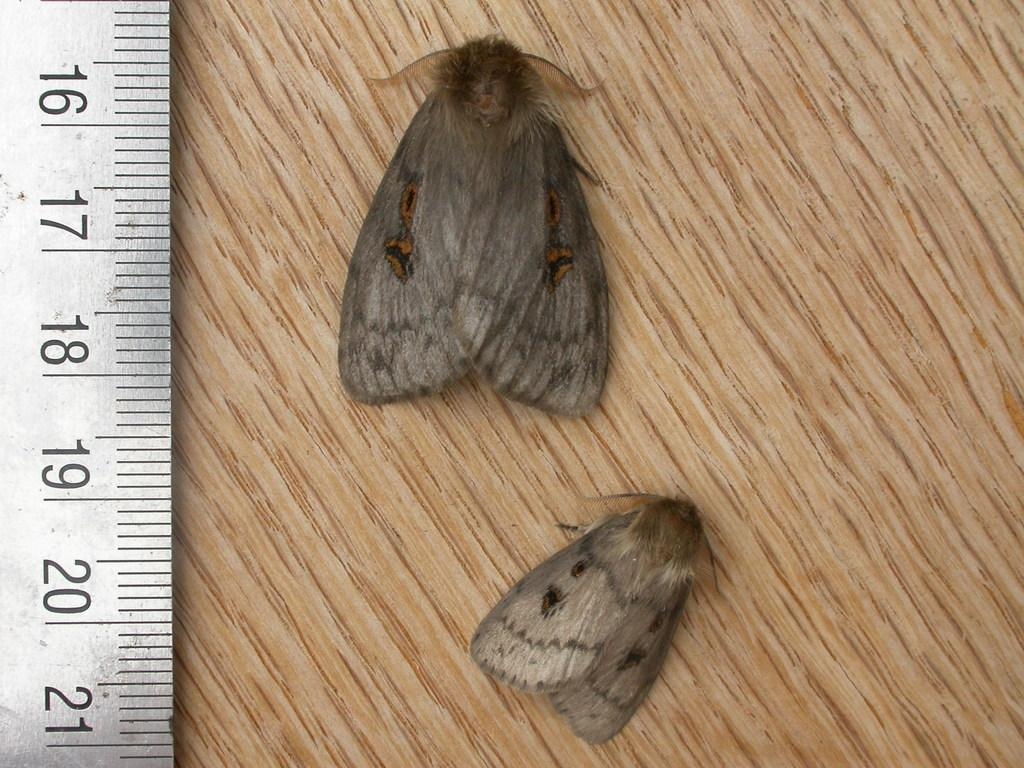How many monkeys are in the image? There are two monkeys in the image. What are the monkeys standing on? The monkeys are standing on a wooden table. What can be seen on the left side of the image? There is a measuring scale on the left side of the image. What type of ring can be seen in the image? There is no ring present in the image. Is there a stream visible in the image? No, there is no stream visible in the image. 